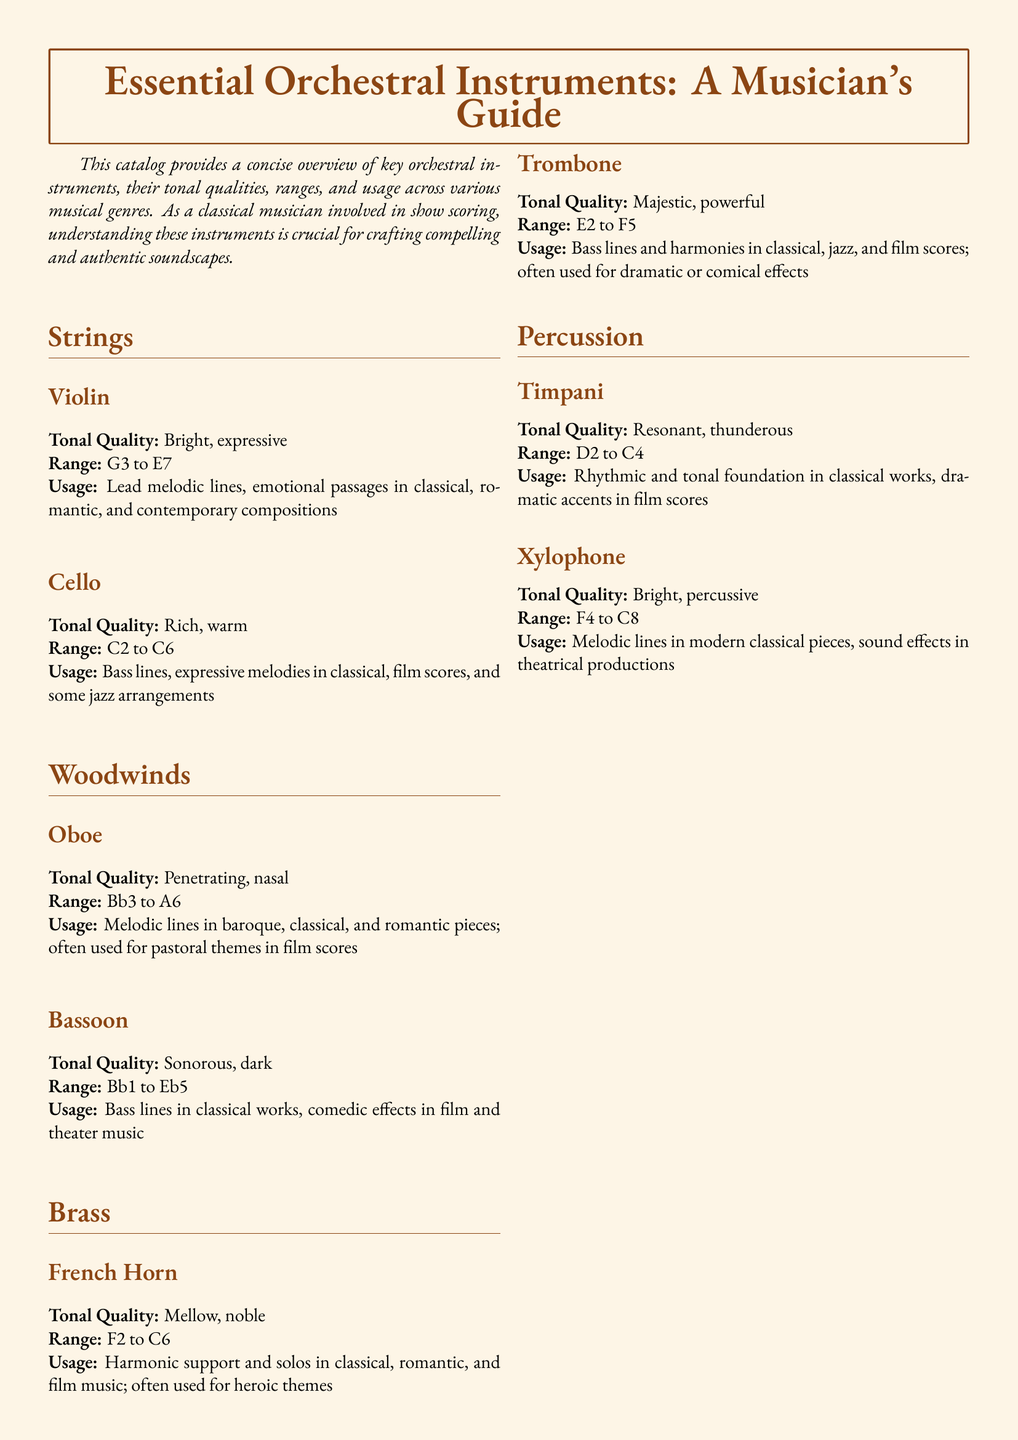what is the tonal quality of the Violin? The tonal quality of the Violin is described as bright and expressive in the document.
Answer: bright, expressive what is the range of the Cello? The range of the Cello is given in the document as C2 to C6.
Answer: C2 to C6 which instrument has a tonal quality described as sonorous? The Bassoon is mentioned in the document as having a sonorous tonal quality.
Answer: Bassoon what is a common usage of the French Horn? The document states that the French Horn is used for harmonic support and solos in classical, romantic, and film music.
Answer: harmonic support and solos what is the highest note range for the Xylophone? The Xylophone's range extends to C8 as noted in the document.
Answer: C8 which woodwind instrument is known for its penetrating tone? The Oboe is noted for its penetrating tonal quality in the document.
Answer: Oboe how is the Trombone commonly used in music? The document mentions that the Trombone is often used for bass lines and harmonies in classical, jazz, and film scores.
Answer: bass lines and harmonies what instrument is associated with pastoral themes in film scores? The Oboe is the instrument associated with pastoral themes in the document.
Answer: Oboe what is the tonal quality of the Timpani? The Timpani is described as having a resonant, thunderous tonal quality in the document.
Answer: resonant, thunderous 